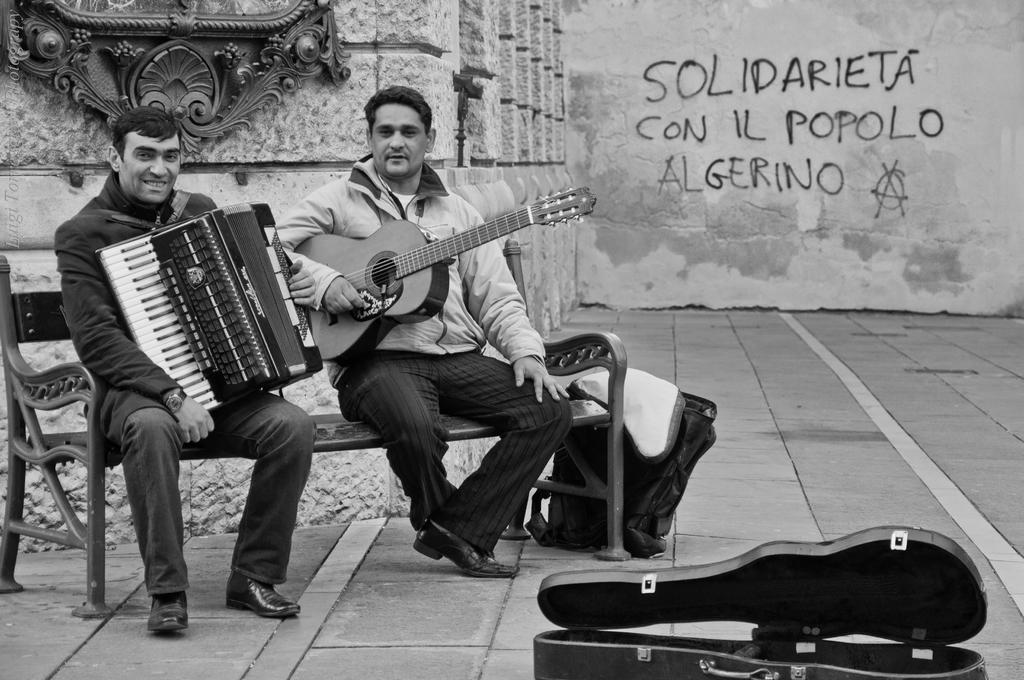Please provide a concise description of this image. In the picture there are two persons sitting on the bench ,two persons are carrying two different musical instruments,near to the person there is a bag beside the bench there is also a box in which the guitar is kept on the floor,back of them there is a wall on the wall there is an architecture,on other wall there is some text written on it. 